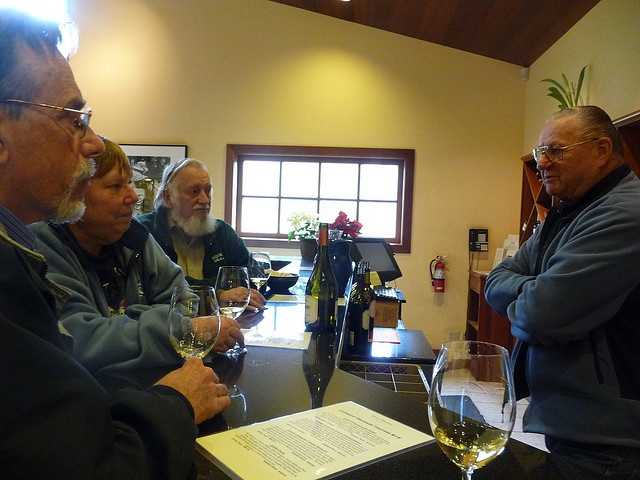Describe the objects in this image and their specific colors. I can see people in white, black, maroon, and gray tones, people in white, black, maroon, gray, and navy tones, people in white, black, gray, maroon, and olive tones, book in white, khaki, tan, and gray tones, and wine glass in white, black, darkgray, gray, and olive tones in this image. 